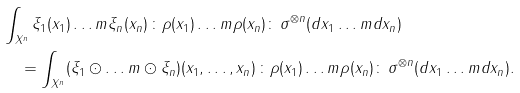<formula> <loc_0><loc_0><loc_500><loc_500>& \int _ { X ^ { n } } \xi _ { 1 } ( x _ { 1 } ) \dots m \xi _ { n } ( x _ { n } ) \, { \colon } \rho ( x _ { 1 } ) \dots m \rho ( x _ { n } ) { \colon } \, \sigma ^ { \otimes n } ( d x _ { 1 } \dots m d x _ { n } ) \\ & \quad = \int _ { X ^ { n } } ( \xi _ { 1 } \odot \dots m \odot \xi _ { n } ) ( x _ { 1 } , \dots , x _ { n } ) \, { \colon } \rho ( x _ { 1 } ) \dots m \rho ( x _ { n } ) { \colon } \, \sigma ^ { \otimes n } ( d x _ { 1 } \dots m d x _ { n } ) .</formula> 